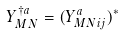<formula> <loc_0><loc_0><loc_500><loc_500>Y _ { M N } ^ { \dag a } = ( Y ^ { a } _ { M N i j } ) ^ { * }</formula> 